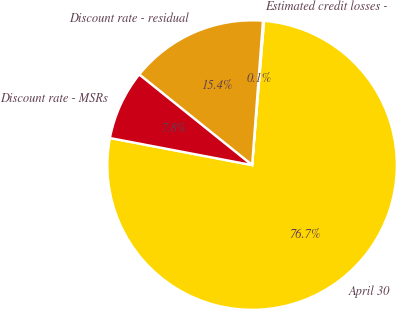Convert chart to OTSL. <chart><loc_0><loc_0><loc_500><loc_500><pie_chart><fcel>April 30<fcel>Estimated credit losses -<fcel>Discount rate - residual<fcel>Discount rate - MSRs<nl><fcel>76.68%<fcel>0.12%<fcel>15.43%<fcel>7.77%<nl></chart> 